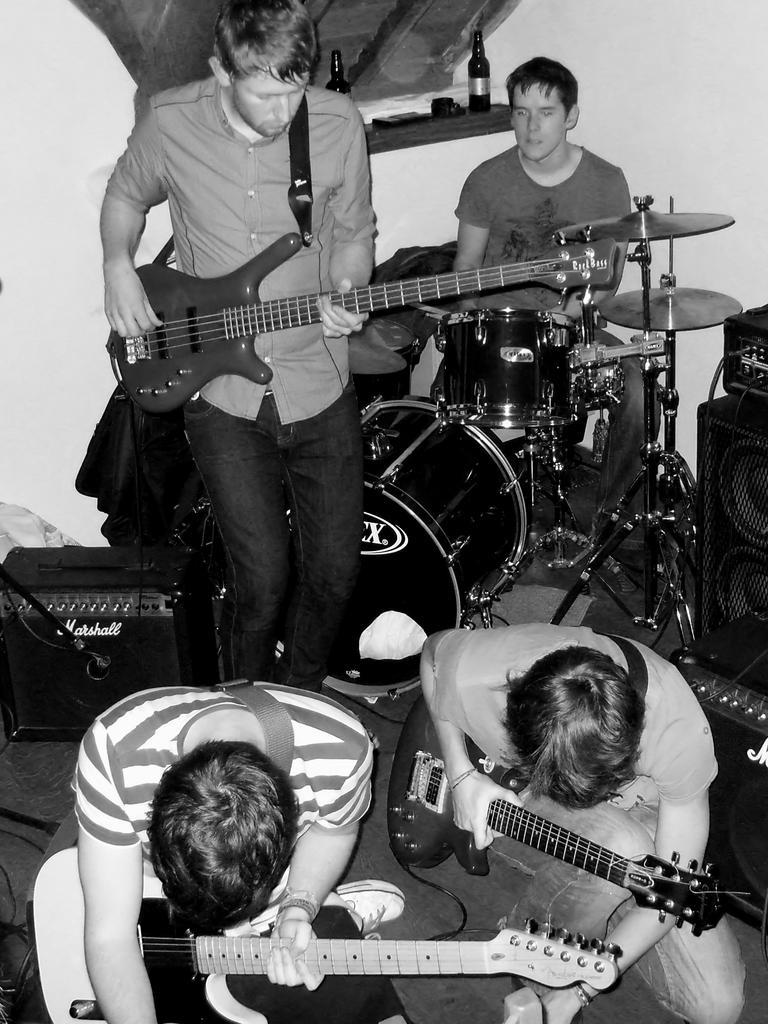How would you summarize this image in a sentence or two? This is a black and white picture. There are a group of people holding the music instruments. Behind the people there is a wall. 